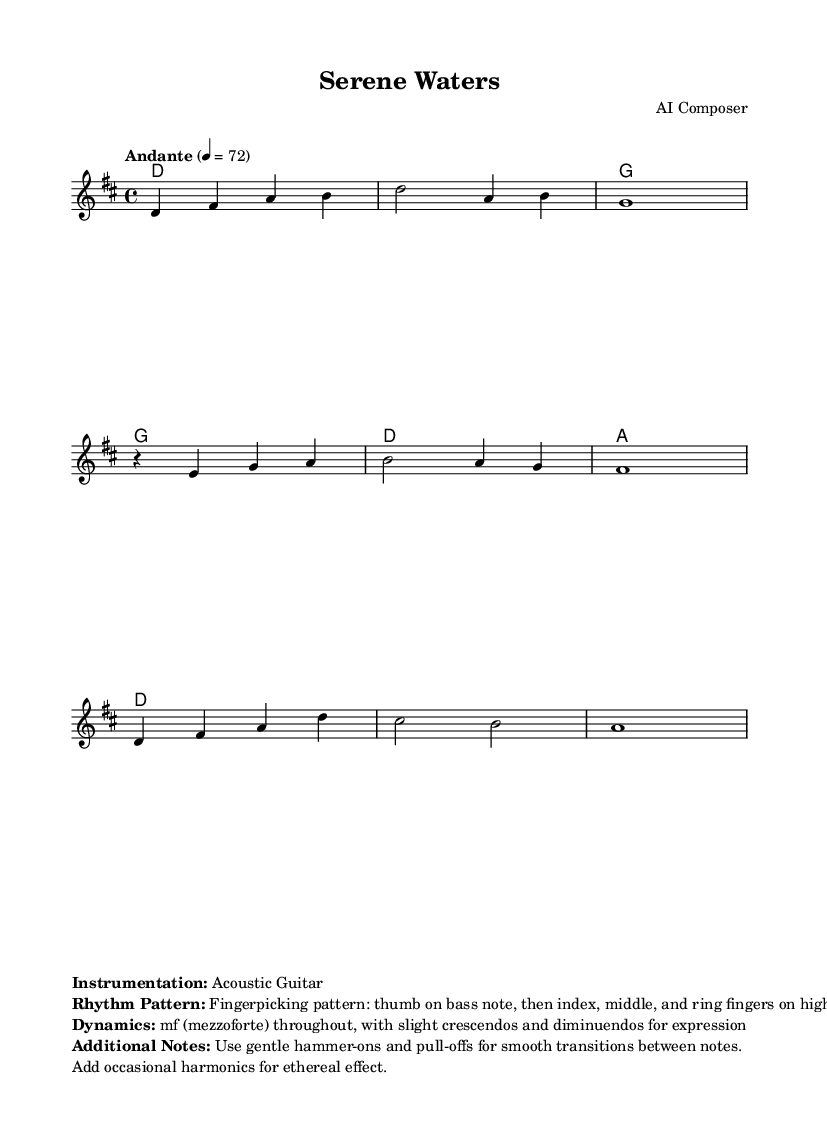What is the key signature of this music? The key signature is two sharps, which corresponds to D major. This is identified at the beginning of the sheet music where the key signature is shown.
Answer: D major What is the time signature of this music? The time signature is indicated at the start of the music, shown as 4 over 4. This means there are four beats per measure and the quarter note gets one beat.
Answer: 4/4 What is the tempo marking for this piece? The tempo marking is found in the header section of the music, indicating a speed of "Andante" at a metronome marking of 72 beats per minute.
Answer: Andante, 72 How many measures are there in the melody? By counting the groups of notes and bars in the melody section, we can see there are 8 measures total. Each measure is separated by vertical lines in the sheet music.
Answer: 8 What is the primary instrument in this piece? The primary instrument is specified in the markup section of the music, clearly stating that it is intended for Acoustic Guitar.
Answer: Acoustic Guitar What type of rhythm pattern is used in this piece? The rhythm pattern is described in the markup section, indicating a fingerpicking pattern which includes the thumb playing the bass notes followed by the index, middle, and ring fingers on higher strings.
Answer: Fingerpicking pattern What dynamics are indicated throughout the piece? The dynamics are specified to be mezzoforte throughout, with instructions for slight crescendos and diminuendos for expressive play. This is indicated in the markup section under dynamics.
Answer: mf (mezzoforte) 